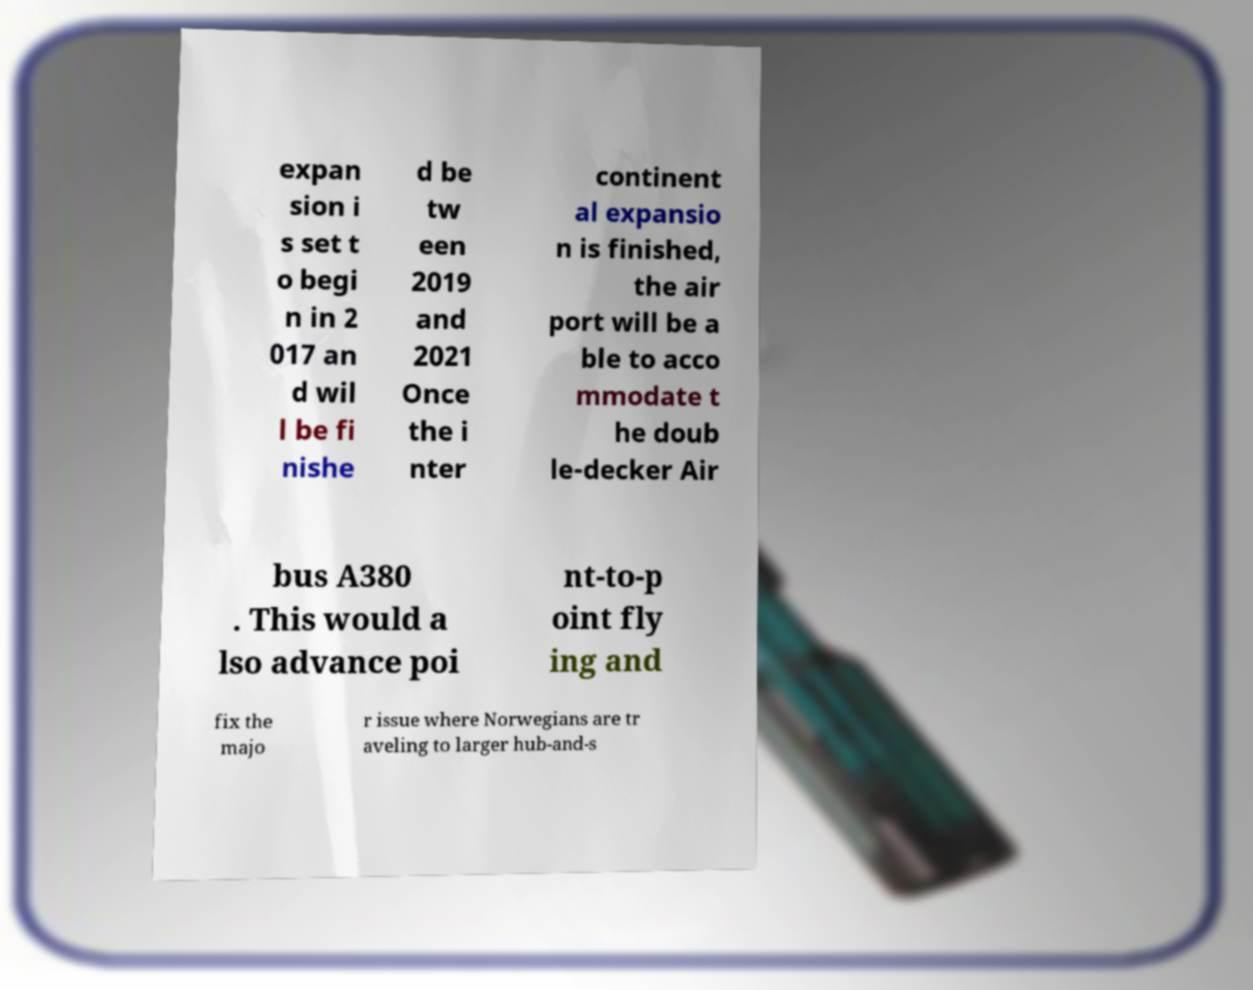Could you assist in decoding the text presented in this image and type it out clearly? expan sion i s set t o begi n in 2 017 an d wil l be fi nishe d be tw een 2019 and 2021 Once the i nter continent al expansio n is finished, the air port will be a ble to acco mmodate t he doub le-decker Air bus A380 . This would a lso advance poi nt-to-p oint fly ing and fix the majo r issue where Norwegians are tr aveling to larger hub-and-s 